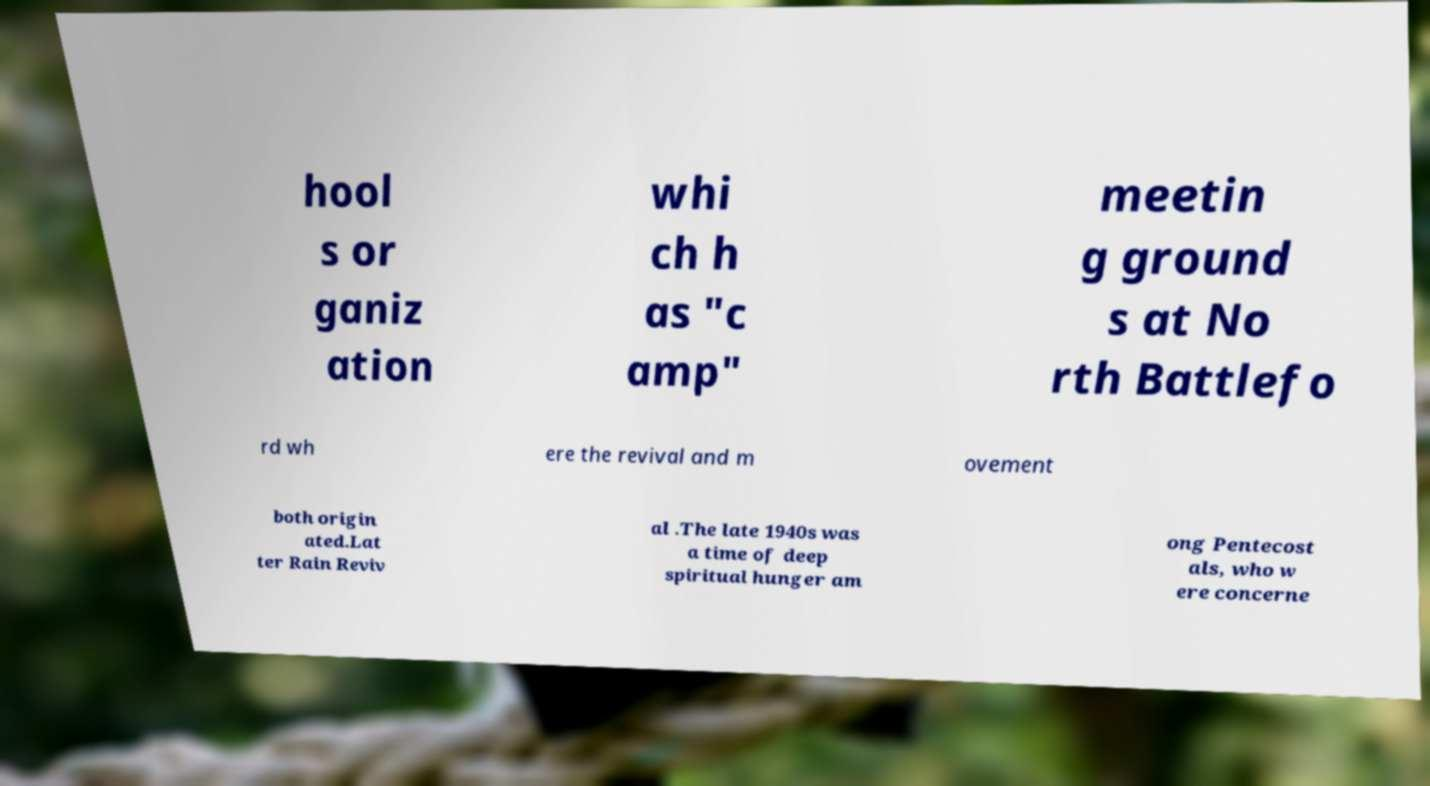Please identify and transcribe the text found in this image. hool s or ganiz ation whi ch h as "c amp" meetin g ground s at No rth Battlefo rd wh ere the revival and m ovement both origin ated.Lat ter Rain Reviv al .The late 1940s was a time of deep spiritual hunger am ong Pentecost als, who w ere concerne 